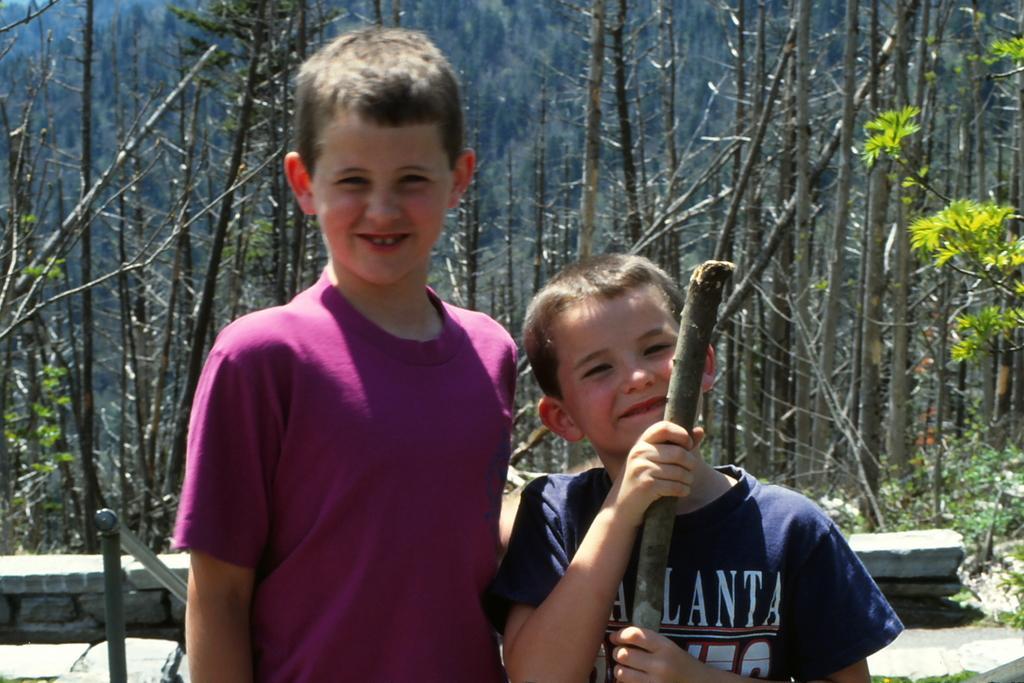How would you summarize this image in a sentence or two? In this image there are two kids standing, in the background there are trees. 